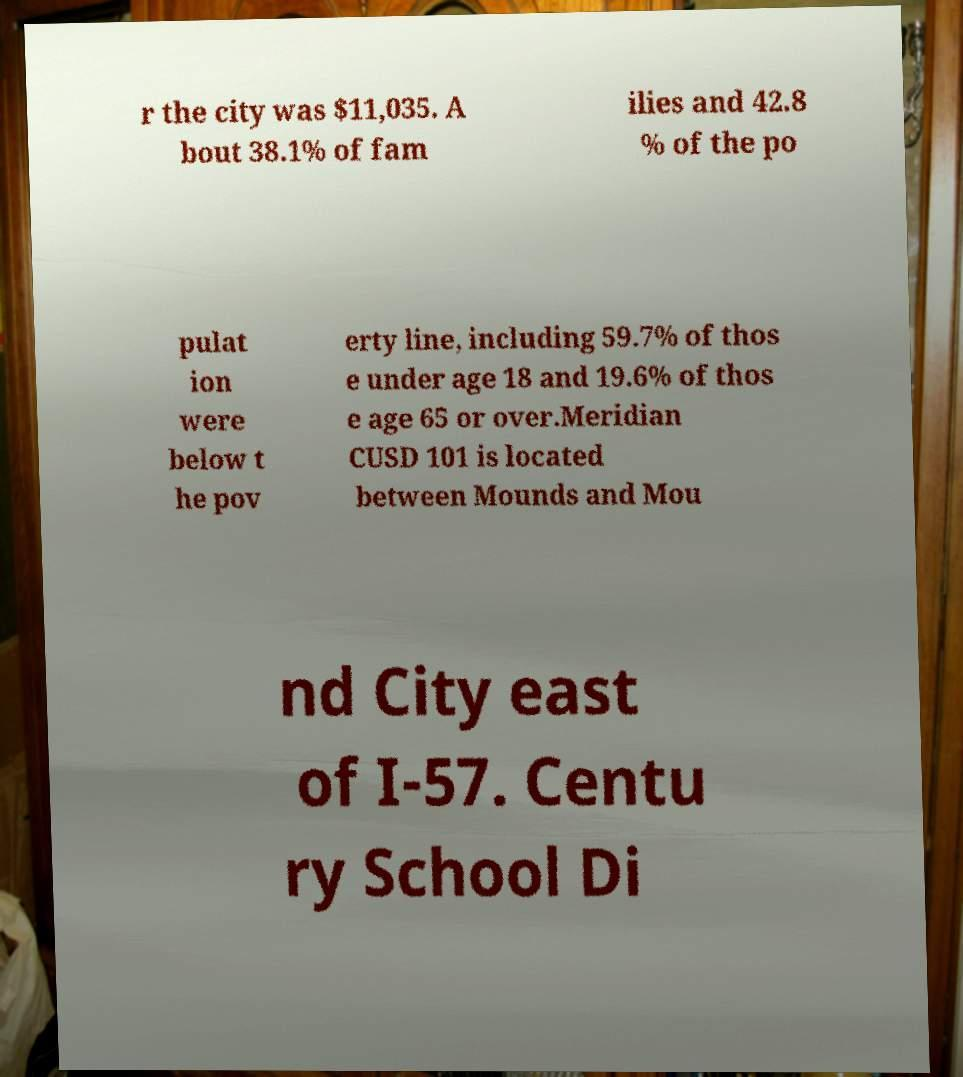I need the written content from this picture converted into text. Can you do that? r the city was $11,035. A bout 38.1% of fam ilies and 42.8 % of the po pulat ion were below t he pov erty line, including 59.7% of thos e under age 18 and 19.6% of thos e age 65 or over.Meridian CUSD 101 is located between Mounds and Mou nd City east of I-57. Centu ry School Di 